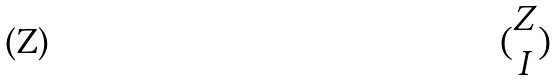<formula> <loc_0><loc_0><loc_500><loc_500>( \begin{matrix} Z \\ I \end{matrix} )</formula> 